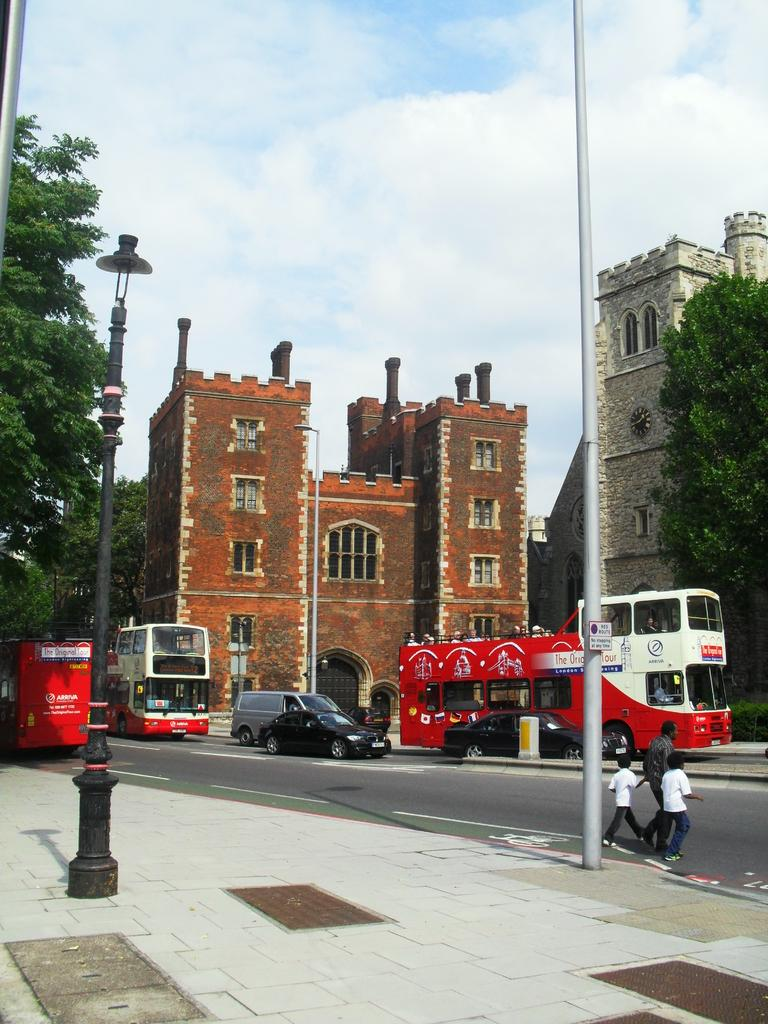What are the persons in the image doing? The persons in the image are walking on the road. What else can be seen on the ground in the image? There are vehicles on the ground. What structures are present in the image besides buildings? There are light poles in the image. What type of natural elements can be seen in the image? There are trees in the image. What is visible in the background of the image? The sky is visible in the image. What type of yarn is being used to cover the trees in the image? There is no yarn or covering present on the trees in the image; they are visible as natural elements. What type of plastic material can be seen in the image? There is no plastic material mentioned or visible in the image. 